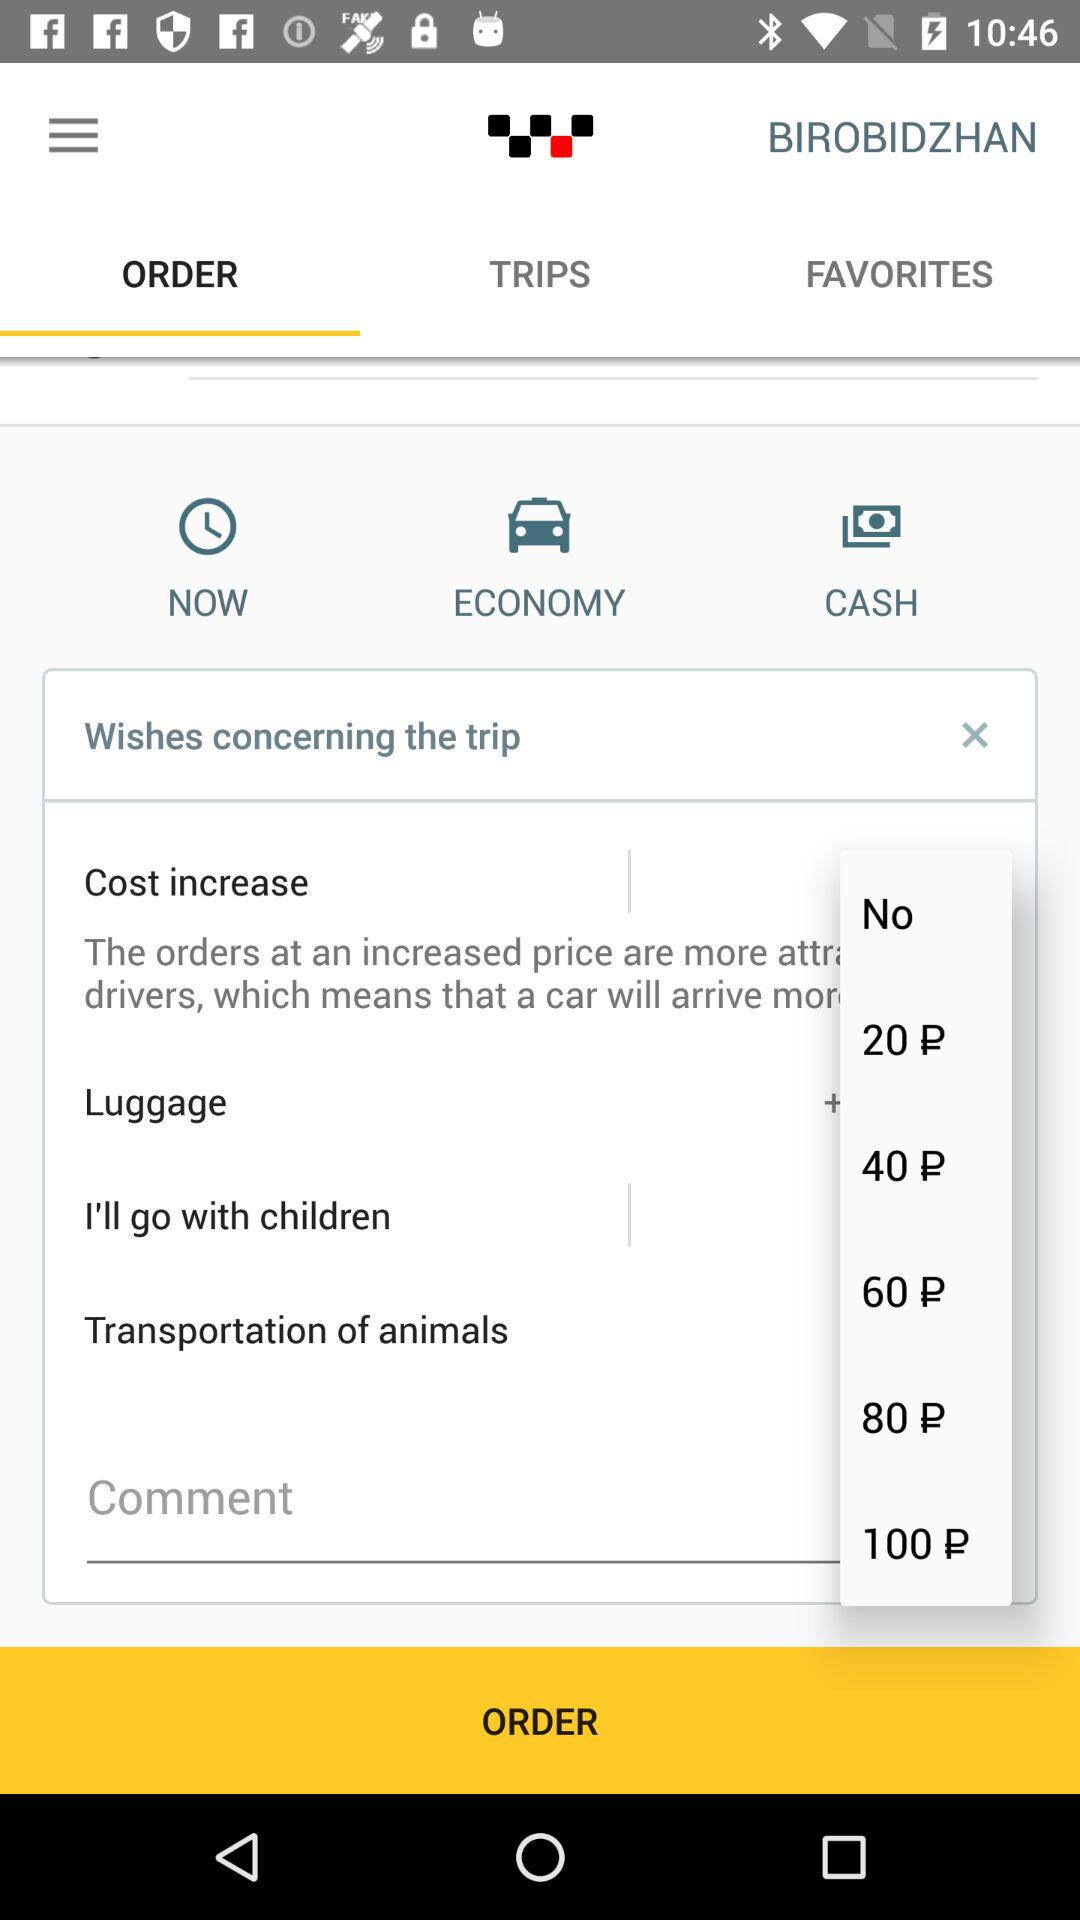What is the name of the application? The name of the application is "BIROBIDZHAN". 